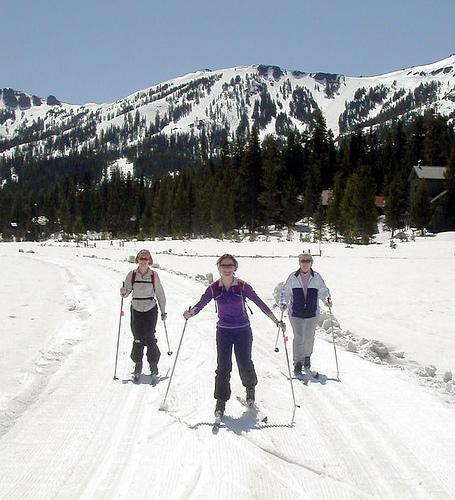How many people are there?
Give a very brief answer. 3. How many dogs are following the horse?
Give a very brief answer. 0. 